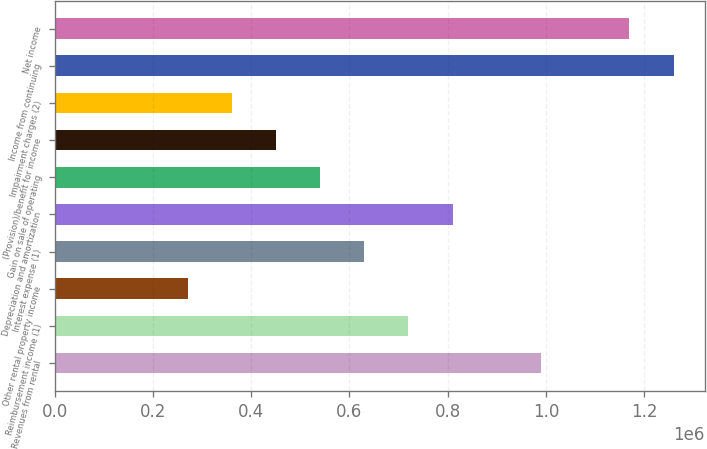Convert chart. <chart><loc_0><loc_0><loc_500><loc_500><bar_chart><fcel>Revenues from rental<fcel>Reimbursement income (1)<fcel>Other rental property income<fcel>Interest expense (1)<fcel>Depreciation and amortization<fcel>Gain on sale of operating<fcel>(Provision)/benefit for income<fcel>Impairment charges (2)<fcel>Income from continuing<fcel>Net income<nl><fcel>990240<fcel>720175<fcel>270066<fcel>630153<fcel>810196<fcel>540131<fcel>450109<fcel>360088<fcel>1.2603e+06<fcel>1.17028e+06<nl></chart> 